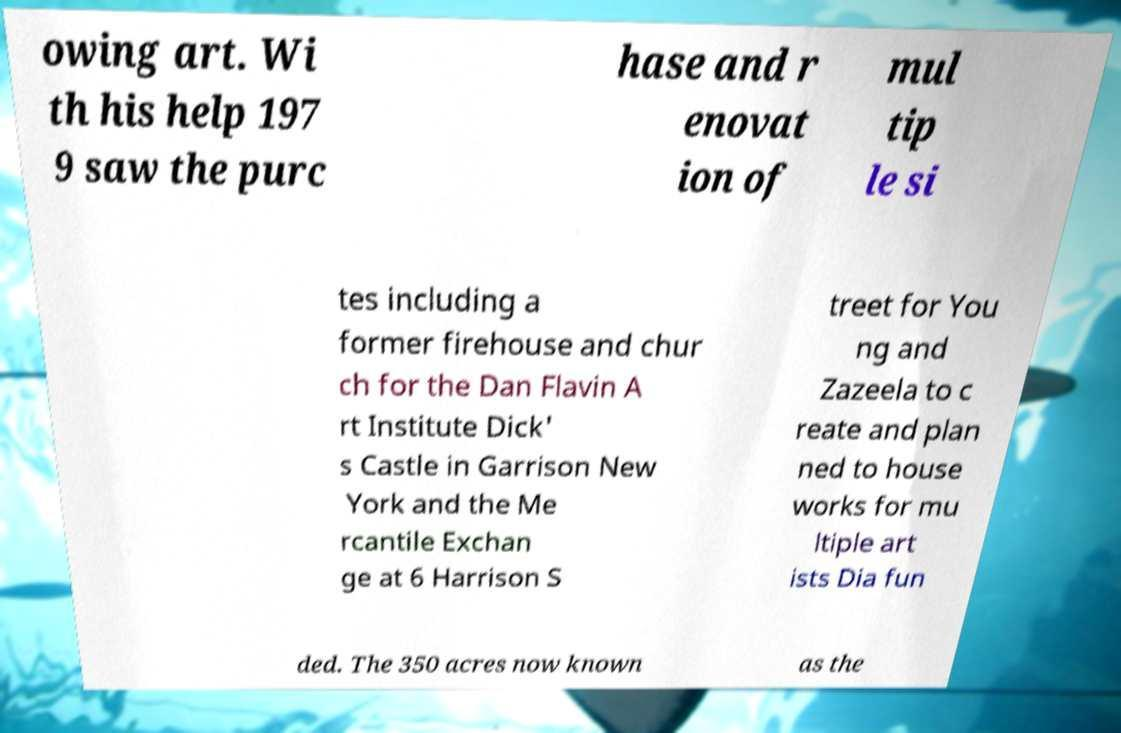Please identify and transcribe the text found in this image. owing art. Wi th his help 197 9 saw the purc hase and r enovat ion of mul tip le si tes including a former firehouse and chur ch for the Dan Flavin A rt Institute Dick' s Castle in Garrison New York and the Me rcantile Exchan ge at 6 Harrison S treet for You ng and Zazeela to c reate and plan ned to house works for mu ltiple art ists Dia fun ded. The 350 acres now known as the 